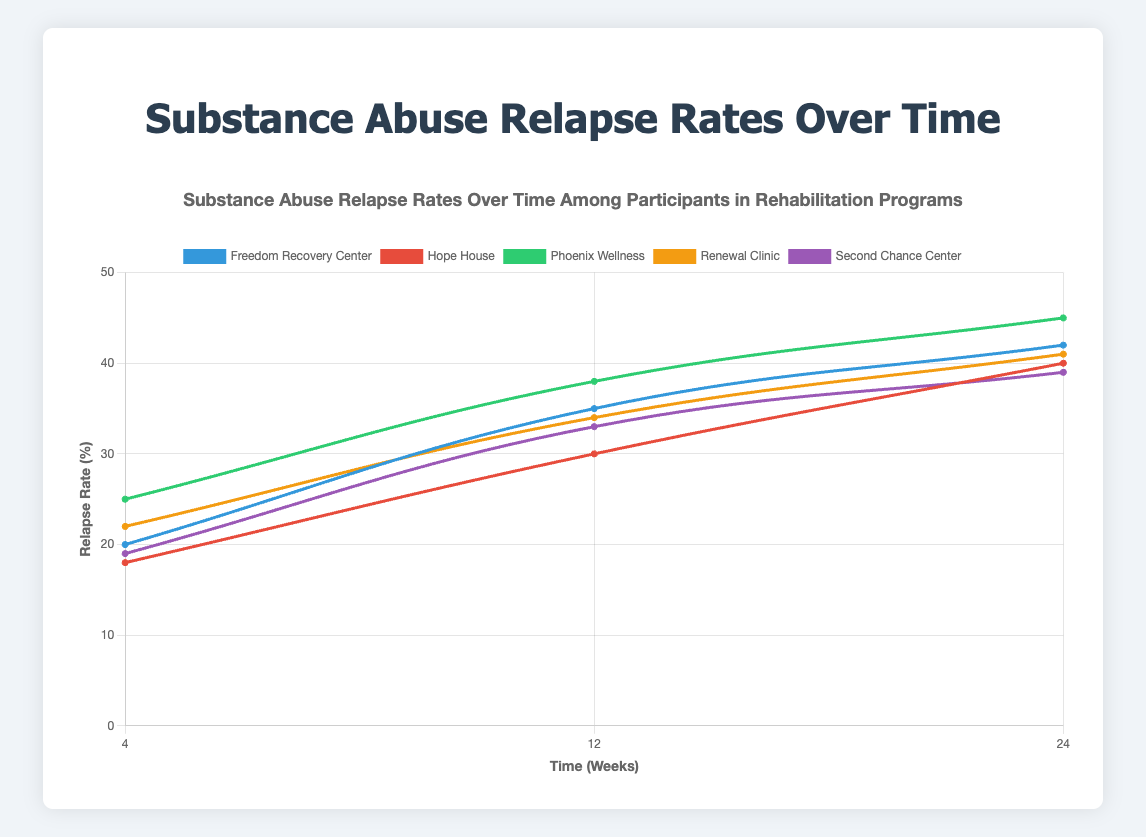What's the relapse rate at 24 weeks for Freedom Recovery Center? The figure shows relapse rates on the y-axis and time periods on the x-axis. For Freedom Recovery Center, find the point corresponding to 24 weeks and read the y-axis value.
Answer: 42% Which program has the lowest relapse rate at 4 weeks? For each program, find the point corresponding to 4 weeks and compare their y-axis values. Identify the program with the smallest value.
Answer: Hope House Which program shows the largest increase in relapse rate from 4 weeks to 12 weeks? Calculate the difference in relapse rate between 4 weeks and 12 weeks for each program. Compare these differences to identify the largest increase. Hope House: (30 - 18) = 12, Freedom Recovery Center: (35 - 20) = 15, Phoenix Wellness: (38 - 25) = 13, Renewal Clinic: (34 - 22) = 12, Second Chance Center: (33 - 19) = 14.
Answer: Freedom Recovery Center Is there any program whose relapse rate remains the same between any two time periods? Check the relapse rates at each time period for all programs. Determine if any program's rates are unchanged between two periods.
Reviewing the provided data, the relapse rates for all programs change at each time period.
Answer: No Which program has the highest overall relapse rate at any point in time? Identify the maximum value of the relapse rates for each program and compare these maxima. The highest relapse rates are: Freedom Recovery Center (42), Hope House (40), Phoenix Wellness (45), Renewal Clinic (41), Second Chance Center (39).
Answer: Phoenix Wellness What's the average relapse rate at 24 weeks across all programs? Add the relapse rates for all programs at 24 weeks and divide by the number of programs: (42 + 40 + 45 + 41 + 39) / 5.
Answer: 41.4% Compare the relapse rate at 12 weeks between Hope House and Renewal Clinic. Why does Hope House have a lower rate? Look at the points for Hope House and Renewal Clinic at 12 weeks and compare their y-axis values. Hope House (30) has a lower relapse rate than Renewal Clinic (34). Both programs start at close rates at 4 weeks but diverge at 12 weeks where Hope House progresses better.
Answer: Hope House has a lower rate At what time period does Phoenix Wellness have the same relapse rate as the 24-week rate of Hope House? Identify the 24-week relapse rate of Hope House (40) and find the time period where Phoenix Wellness has the same rate. At 12 weeks, Phoenix Wellness has a rate of 38, and at 24 weeks, it is 45, thus Phoenix Wellness does not have the same rate at any period.
Answer: No matching period What is the overall trend for the relapse rates in all programs over time? Look at the general direction of the curves for all programs from 4 to 24 weeks. All curves show an upward trend, indicating increased relapse rates over time.
Answer: Upward trend 